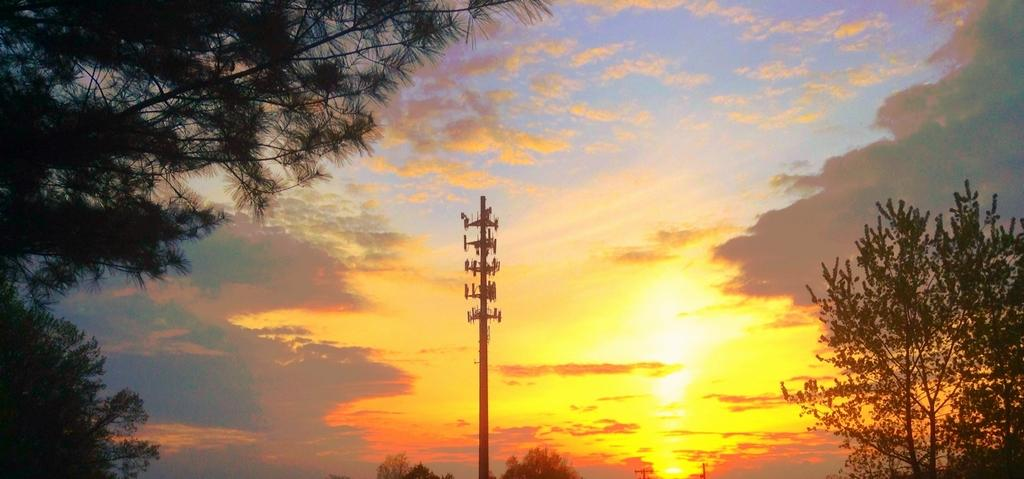What is the main object in the image? There is a pole in the image. What can be seen on the left side of the image? There are trees on the left side of the image. What can be seen on the right side of the image? There are trees on the right side of the image. What is visible in the background of the image? The sky is visible in the background of the image. Can you tell me the rhythm of the music playing in the image? There is no music or rhythm present in the image; it only features a pole and trees. 